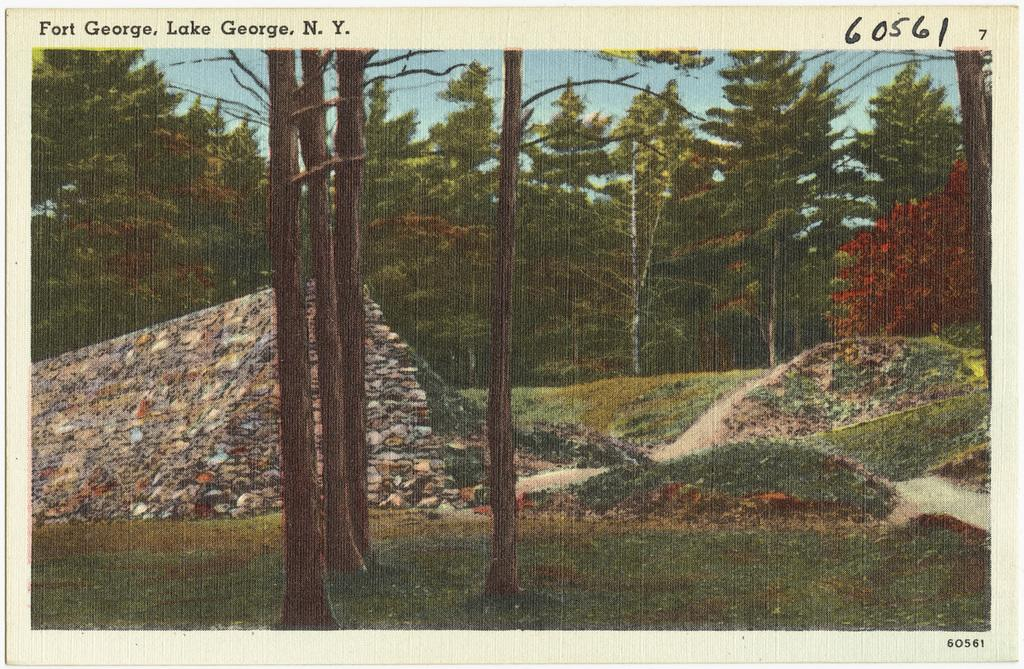How many tree trunks are visible in the image? There are four tree trunks in the image. What else can be seen in the background of the image? There are trees in the background of the image. What is written above the tree trunks? Unfortunately, the provided facts do not mention what is written above the tree trunks. How many legs can be seen on the cows in the image? There are no cows present in the image, so it is not possible to determine how many legs they might have. 